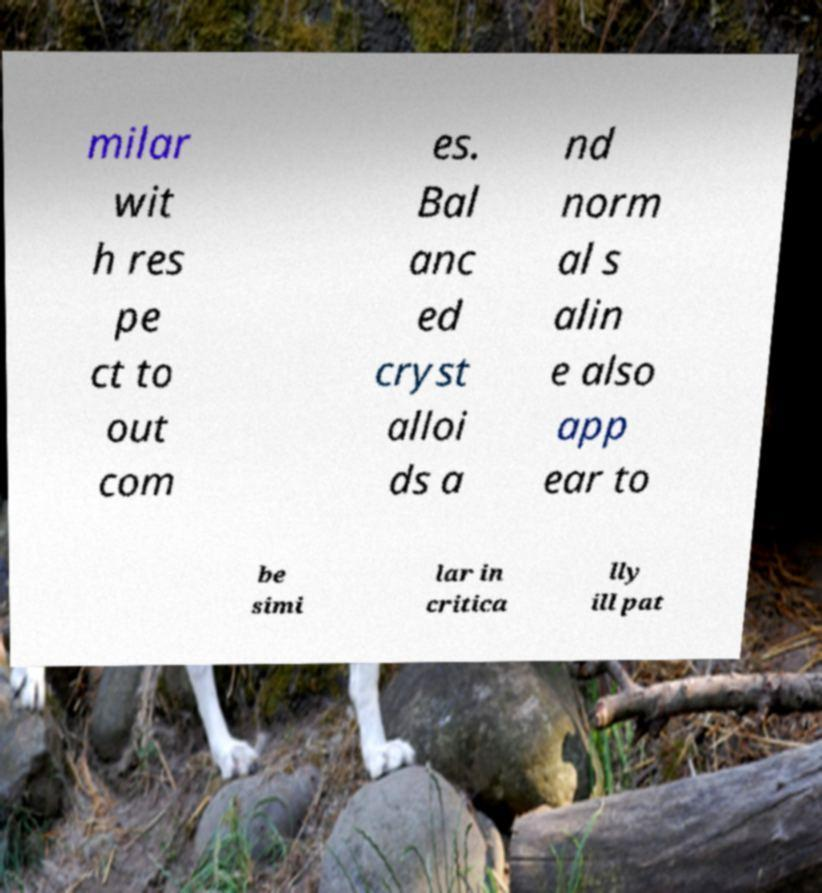Can you accurately transcribe the text from the provided image for me? milar wit h res pe ct to out com es. Bal anc ed cryst alloi ds a nd norm al s alin e also app ear to be simi lar in critica lly ill pat 